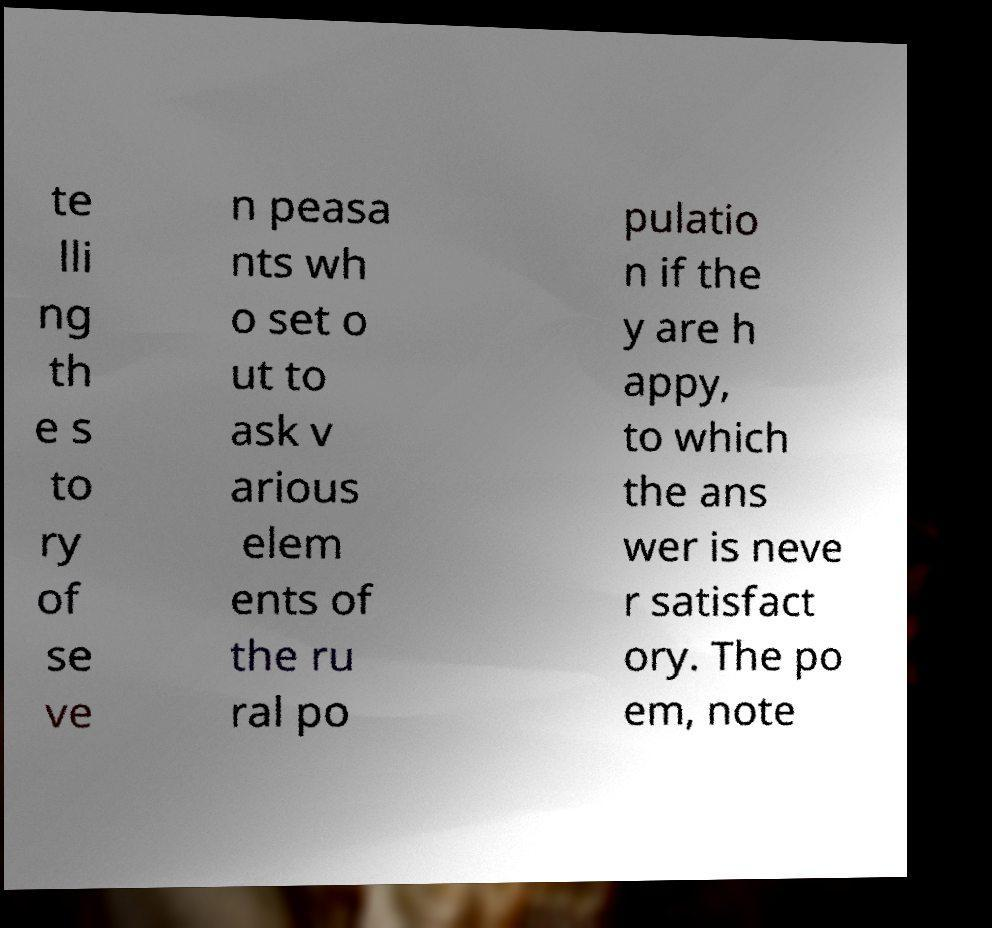Please read and relay the text visible in this image. What does it say? te lli ng th e s to ry of se ve n peasa nts wh o set o ut to ask v arious elem ents of the ru ral po pulatio n if the y are h appy, to which the ans wer is neve r satisfact ory. The po em, note 